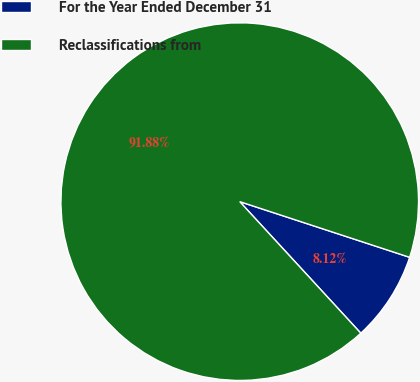Convert chart to OTSL. <chart><loc_0><loc_0><loc_500><loc_500><pie_chart><fcel>For the Year Ended December 31<fcel>Reclassifications from<nl><fcel>8.12%<fcel>91.88%<nl></chart> 